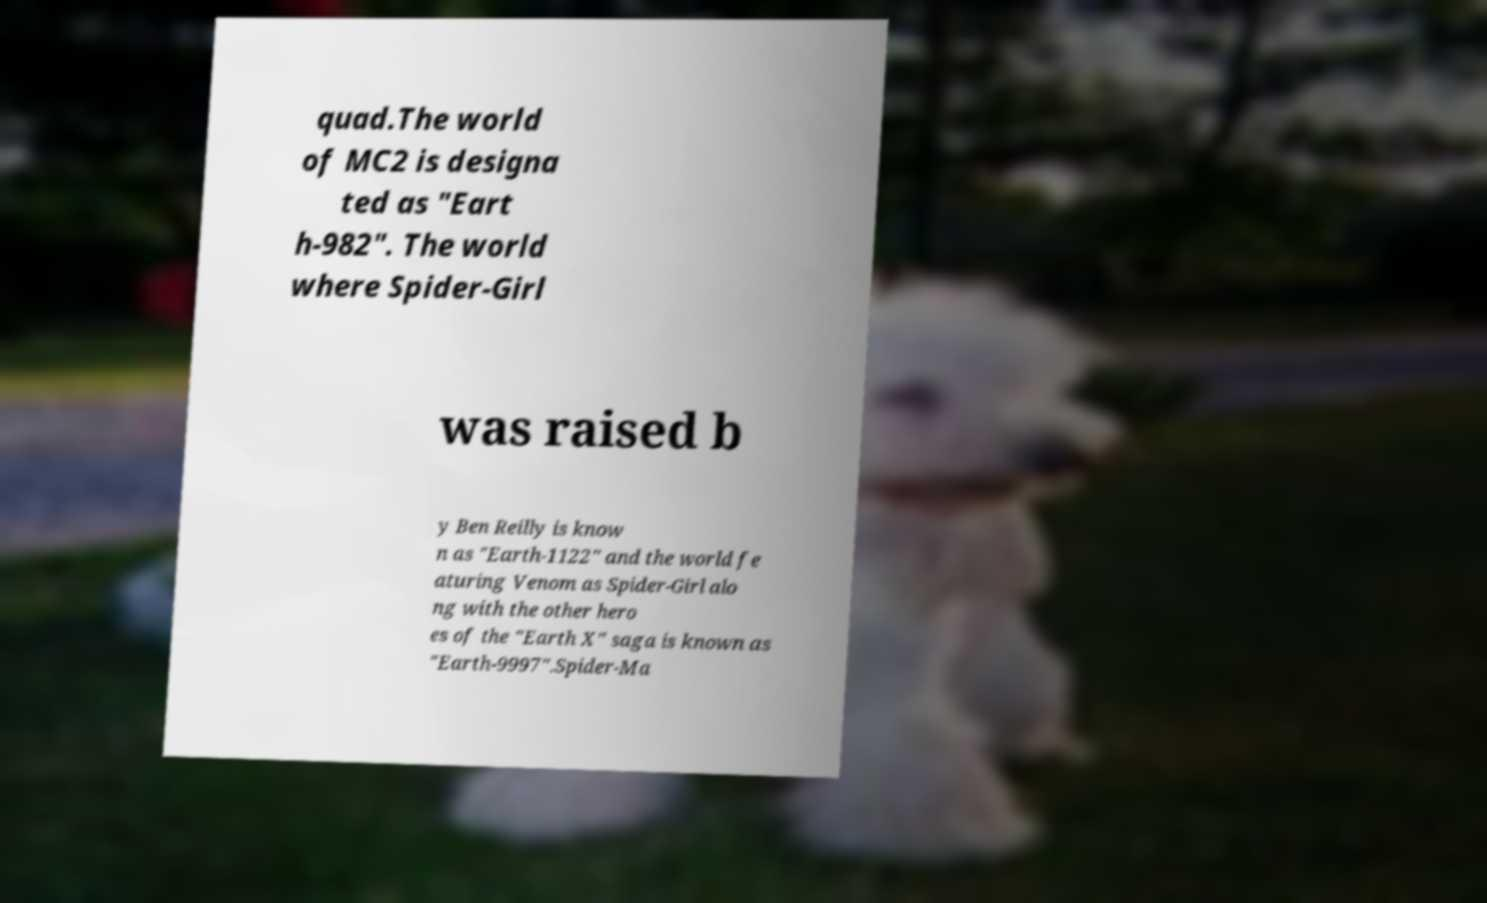Can you read and provide the text displayed in the image?This photo seems to have some interesting text. Can you extract and type it out for me? quad.The world of MC2 is designa ted as "Eart h-982". The world where Spider-Girl was raised b y Ben Reilly is know n as "Earth-1122" and the world fe aturing Venom as Spider-Girl alo ng with the other hero es of the "Earth X" saga is known as "Earth-9997".Spider-Ma 